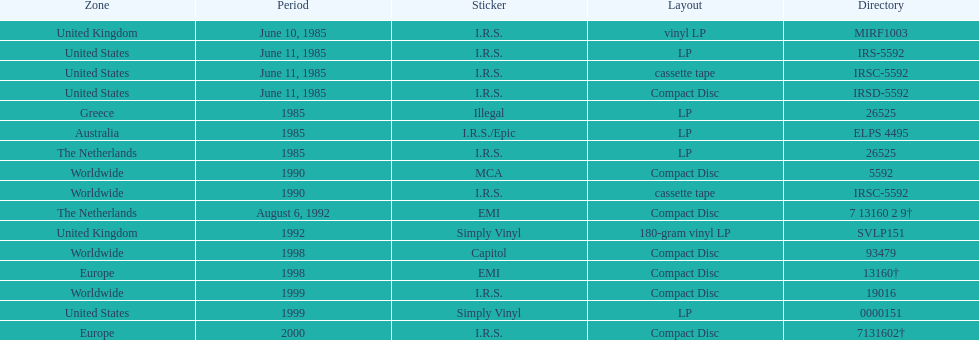Which region has more than one format? United States. 